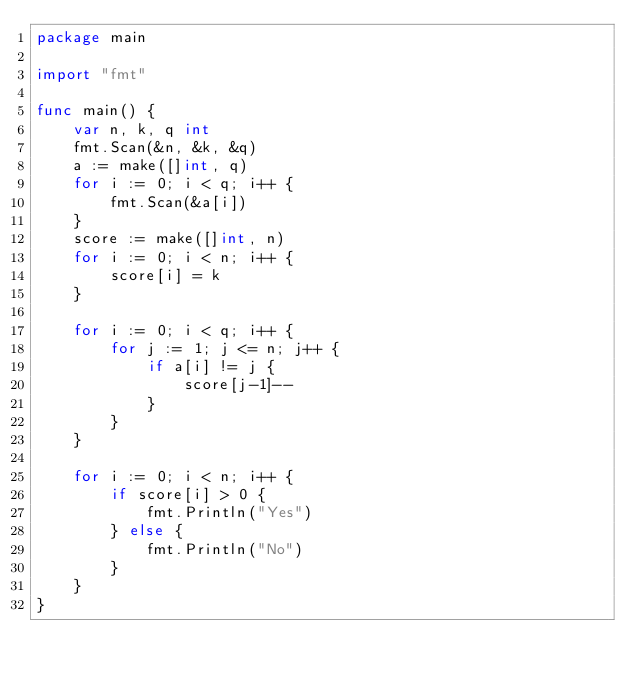Convert code to text. <code><loc_0><loc_0><loc_500><loc_500><_Go_>package main

import "fmt"

func main() {
	var n, k, q int
	fmt.Scan(&n, &k, &q)
	a := make([]int, q)
	for i := 0; i < q; i++ {
		fmt.Scan(&a[i])
	}
	score := make([]int, n)
	for i := 0; i < n; i++ {
		score[i] = k
	}

	for i := 0; i < q; i++ {
		for j := 1; j <= n; j++ {
			if a[i] != j {
				score[j-1]--
			}
		}
	}

	for i := 0; i < n; i++ {
		if score[i] > 0 {
			fmt.Println("Yes")
		} else {
			fmt.Println("No")
		}
	}
}
</code> 